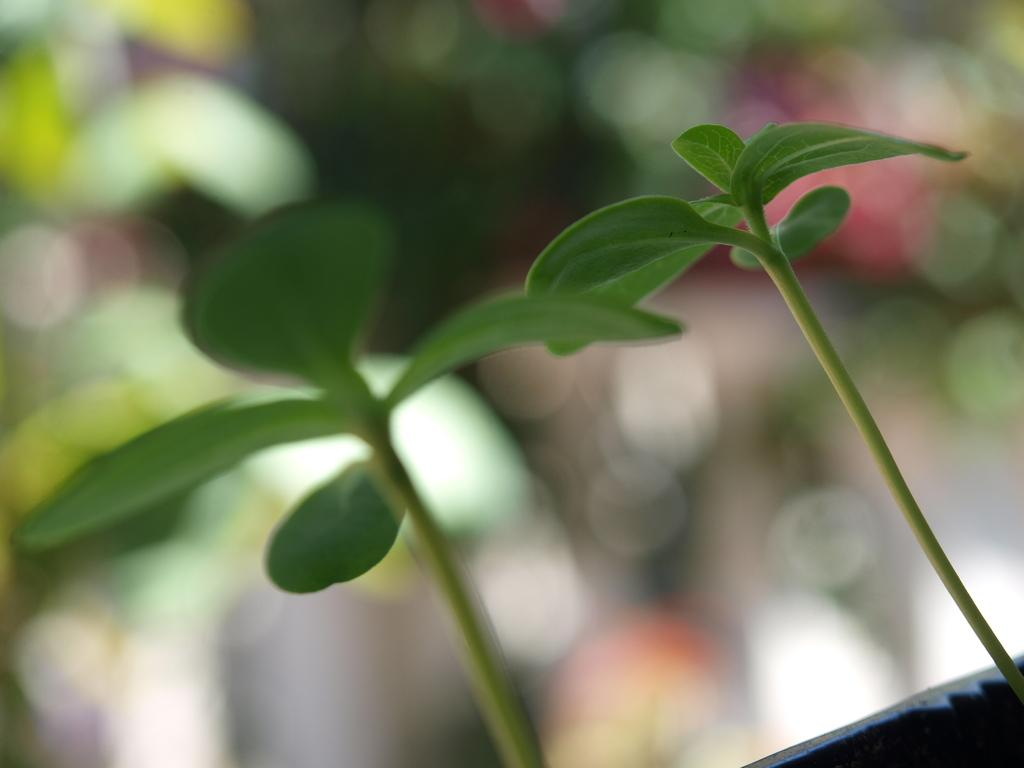What type of plants can be seen in the image? There are two plants with green leaves in the image. Can you describe the background of the image? The background of the image is blurry. What type of muscle can be seen flexing in the image? There is no muscle present in the image; it features two plants with green leaves. How many tramps are visible in the image? There are no tramps present in the image. 